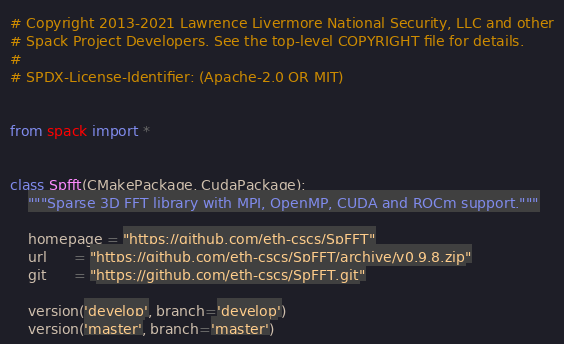Convert code to text. <code><loc_0><loc_0><loc_500><loc_500><_Python_># Copyright 2013-2021 Lawrence Livermore National Security, LLC and other
# Spack Project Developers. See the top-level COPYRIGHT file for details.
#
# SPDX-License-Identifier: (Apache-2.0 OR MIT)


from spack import *


class Spfft(CMakePackage, CudaPackage):
    """Sparse 3D FFT library with MPI, OpenMP, CUDA and ROCm support."""

    homepage = "https://github.com/eth-cscs/SpFFT"
    url      = "https://github.com/eth-cscs/SpFFT/archive/v0.9.8.zip"
    git      = "https://github.com/eth-cscs/SpFFT.git"

    version('develop', branch='develop')
    version('master', branch='master')
</code> 